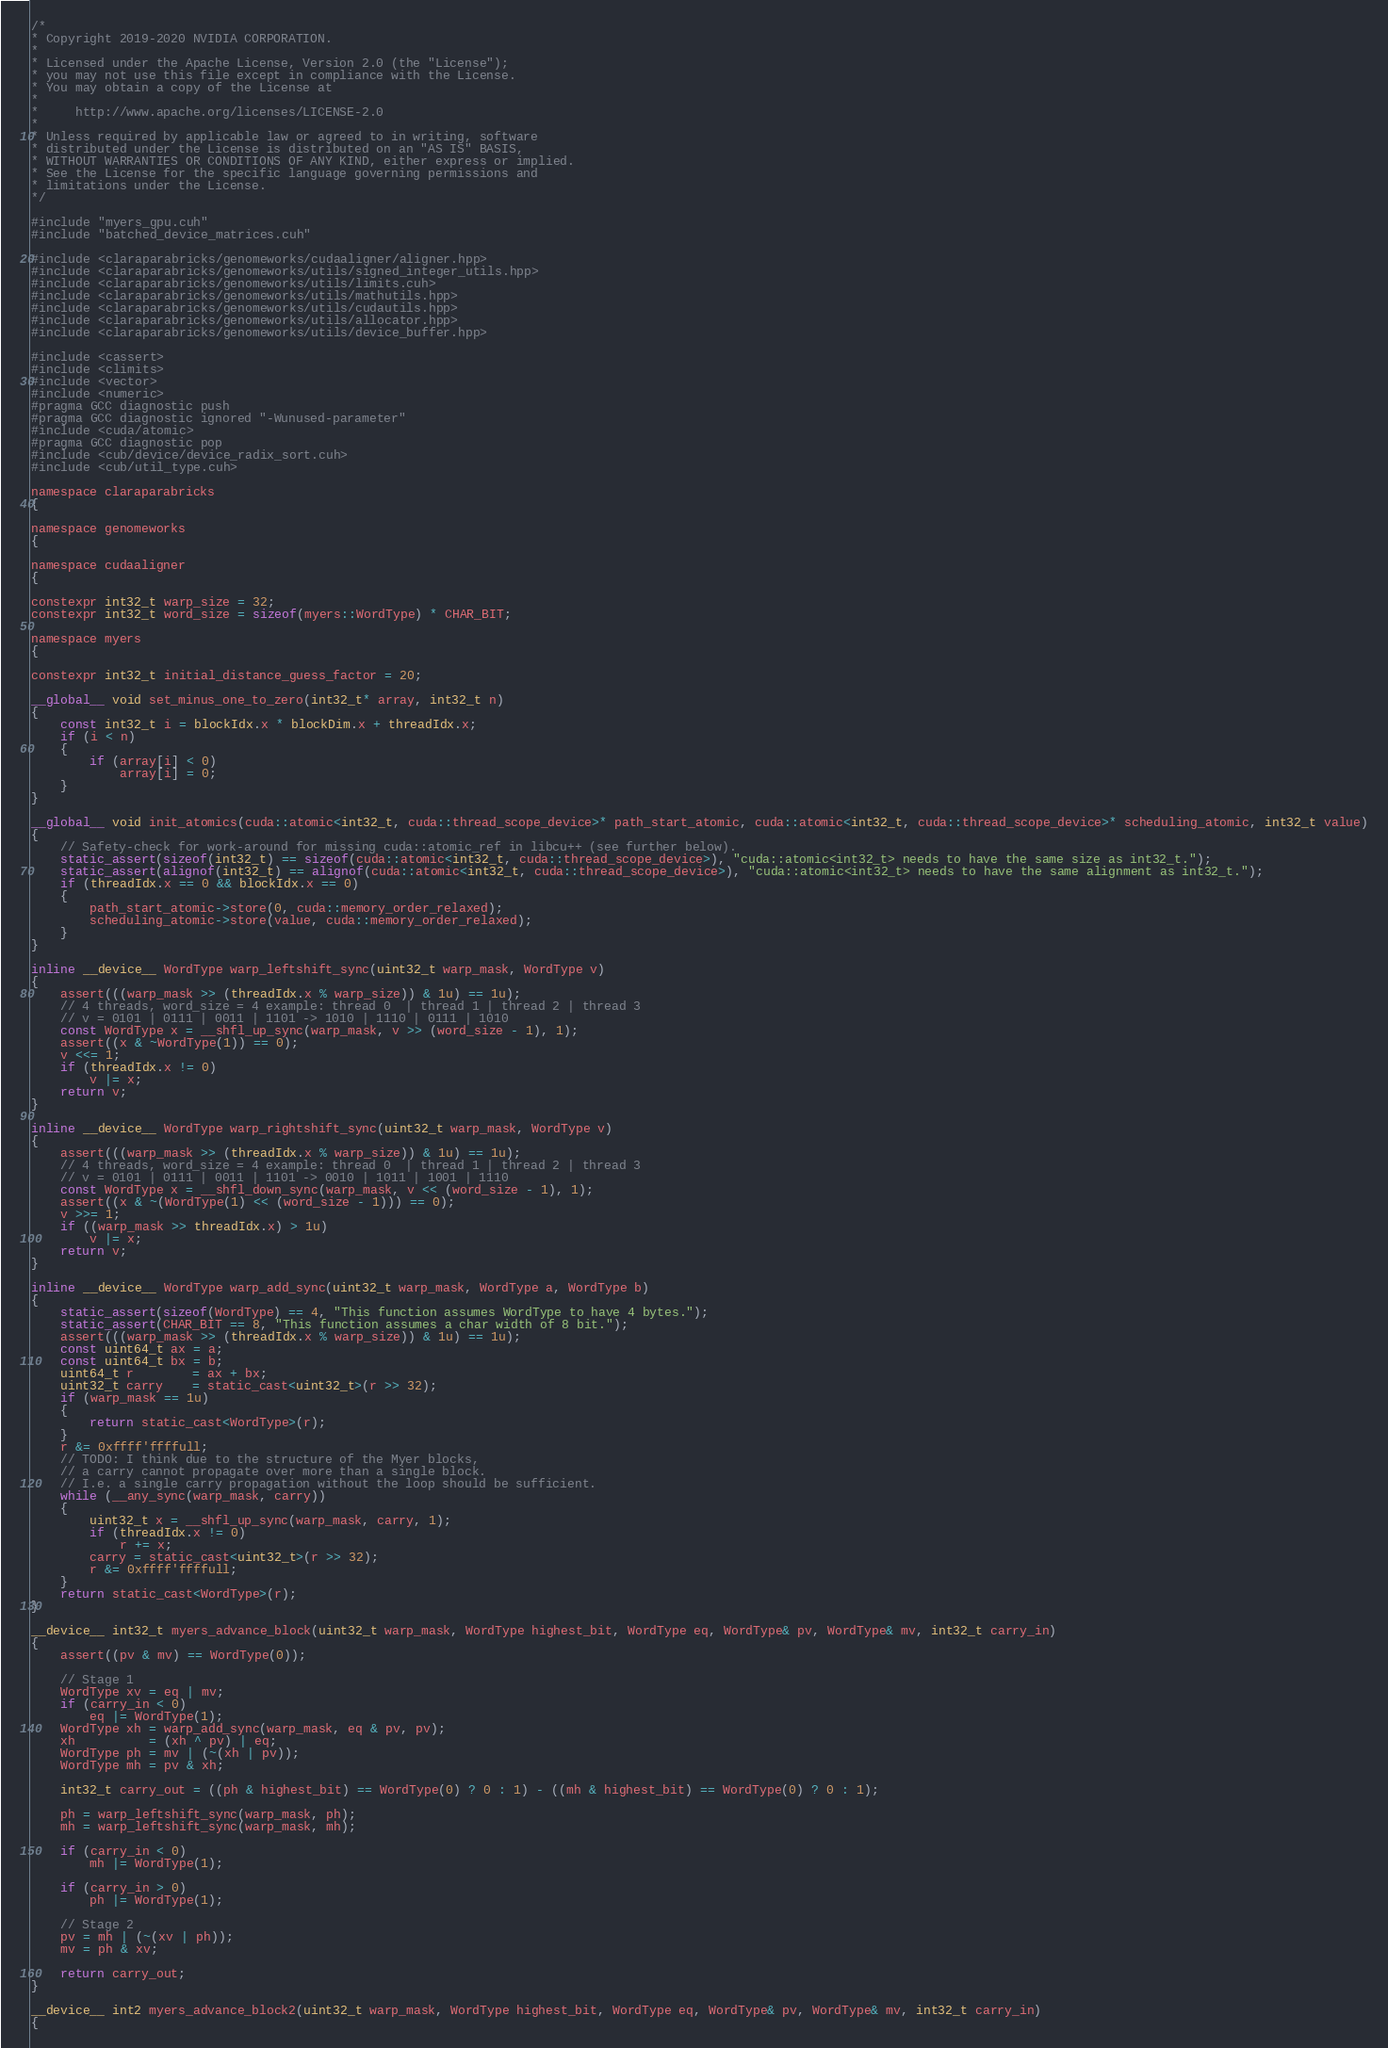<code> <loc_0><loc_0><loc_500><loc_500><_Cuda_>/*
* Copyright 2019-2020 NVIDIA CORPORATION.
*
* Licensed under the Apache License, Version 2.0 (the "License");
* you may not use this file except in compliance with the License.
* You may obtain a copy of the License at
*
*     http://www.apache.org/licenses/LICENSE-2.0
*
* Unless required by applicable law or agreed to in writing, software
* distributed under the License is distributed on an "AS IS" BASIS,
* WITHOUT WARRANTIES OR CONDITIONS OF ANY KIND, either express or implied.
* See the License for the specific language governing permissions and
* limitations under the License.
*/

#include "myers_gpu.cuh"
#include "batched_device_matrices.cuh"

#include <claraparabricks/genomeworks/cudaaligner/aligner.hpp>
#include <claraparabricks/genomeworks/utils/signed_integer_utils.hpp>
#include <claraparabricks/genomeworks/utils/limits.cuh>
#include <claraparabricks/genomeworks/utils/mathutils.hpp>
#include <claraparabricks/genomeworks/utils/cudautils.hpp>
#include <claraparabricks/genomeworks/utils/allocator.hpp>
#include <claraparabricks/genomeworks/utils/device_buffer.hpp>

#include <cassert>
#include <climits>
#include <vector>
#include <numeric>
#pragma GCC diagnostic push
#pragma GCC diagnostic ignored "-Wunused-parameter"
#include <cuda/atomic>
#pragma GCC diagnostic pop
#include <cub/device/device_radix_sort.cuh>
#include <cub/util_type.cuh>

namespace claraparabricks
{

namespace genomeworks
{

namespace cudaaligner
{

constexpr int32_t warp_size = 32;
constexpr int32_t word_size = sizeof(myers::WordType) * CHAR_BIT;

namespace myers
{

constexpr int32_t initial_distance_guess_factor = 20;

__global__ void set_minus_one_to_zero(int32_t* array, int32_t n)
{
    const int32_t i = blockIdx.x * blockDim.x + threadIdx.x;
    if (i < n)
    {
        if (array[i] < 0)
            array[i] = 0;
    }
}

__global__ void init_atomics(cuda::atomic<int32_t, cuda::thread_scope_device>* path_start_atomic, cuda::atomic<int32_t, cuda::thread_scope_device>* scheduling_atomic, int32_t value)
{
    // Safety-check for work-around for missing cuda::atomic_ref in libcu++ (see further below).
    static_assert(sizeof(int32_t) == sizeof(cuda::atomic<int32_t, cuda::thread_scope_device>), "cuda::atomic<int32_t> needs to have the same size as int32_t.");
    static_assert(alignof(int32_t) == alignof(cuda::atomic<int32_t, cuda::thread_scope_device>), "cuda::atomic<int32_t> needs to have the same alignment as int32_t.");
    if (threadIdx.x == 0 && blockIdx.x == 0)
    {
        path_start_atomic->store(0, cuda::memory_order_relaxed);
        scheduling_atomic->store(value, cuda::memory_order_relaxed);
    }
}

inline __device__ WordType warp_leftshift_sync(uint32_t warp_mask, WordType v)
{
    assert(((warp_mask >> (threadIdx.x % warp_size)) & 1u) == 1u);
    // 4 threads, word_size = 4 example: thread 0  | thread 1 | thread 2 | thread 3
    // v = 0101 | 0111 | 0011 | 1101 -> 1010 | 1110 | 0111 | 1010
    const WordType x = __shfl_up_sync(warp_mask, v >> (word_size - 1), 1);
    assert((x & ~WordType(1)) == 0);
    v <<= 1;
    if (threadIdx.x != 0)
        v |= x;
    return v;
}

inline __device__ WordType warp_rightshift_sync(uint32_t warp_mask, WordType v)
{
    assert(((warp_mask >> (threadIdx.x % warp_size)) & 1u) == 1u);
    // 4 threads, word_size = 4 example: thread 0  | thread 1 | thread 2 | thread 3
    // v = 0101 | 0111 | 0011 | 1101 -> 0010 | 1011 | 1001 | 1110
    const WordType x = __shfl_down_sync(warp_mask, v << (word_size - 1), 1);
    assert((x & ~(WordType(1) << (word_size - 1))) == 0);
    v >>= 1;
    if ((warp_mask >> threadIdx.x) > 1u)
        v |= x;
    return v;
}

inline __device__ WordType warp_add_sync(uint32_t warp_mask, WordType a, WordType b)
{
    static_assert(sizeof(WordType) == 4, "This function assumes WordType to have 4 bytes.");
    static_assert(CHAR_BIT == 8, "This function assumes a char width of 8 bit.");
    assert(((warp_mask >> (threadIdx.x % warp_size)) & 1u) == 1u);
    const uint64_t ax = a;
    const uint64_t bx = b;
    uint64_t r        = ax + bx;
    uint32_t carry    = static_cast<uint32_t>(r >> 32);
    if (warp_mask == 1u)
    {
        return static_cast<WordType>(r);
    }
    r &= 0xffff'ffffull;
    // TODO: I think due to the structure of the Myer blocks,
    // a carry cannot propagate over more than a single block.
    // I.e. a single carry propagation without the loop should be sufficient.
    while (__any_sync(warp_mask, carry))
    {
        uint32_t x = __shfl_up_sync(warp_mask, carry, 1);
        if (threadIdx.x != 0)
            r += x;
        carry = static_cast<uint32_t>(r >> 32);
        r &= 0xffff'ffffull;
    }
    return static_cast<WordType>(r);
}

__device__ int32_t myers_advance_block(uint32_t warp_mask, WordType highest_bit, WordType eq, WordType& pv, WordType& mv, int32_t carry_in)
{
    assert((pv & mv) == WordType(0));

    // Stage 1
    WordType xv = eq | mv;
    if (carry_in < 0)
        eq |= WordType(1);
    WordType xh = warp_add_sync(warp_mask, eq & pv, pv);
    xh          = (xh ^ pv) | eq;
    WordType ph = mv | (~(xh | pv));
    WordType mh = pv & xh;

    int32_t carry_out = ((ph & highest_bit) == WordType(0) ? 0 : 1) - ((mh & highest_bit) == WordType(0) ? 0 : 1);

    ph = warp_leftshift_sync(warp_mask, ph);
    mh = warp_leftshift_sync(warp_mask, mh);

    if (carry_in < 0)
        mh |= WordType(1);

    if (carry_in > 0)
        ph |= WordType(1);

    // Stage 2
    pv = mh | (~(xv | ph));
    mv = ph & xv;

    return carry_out;
}

__device__ int2 myers_advance_block2(uint32_t warp_mask, WordType highest_bit, WordType eq, WordType& pv, WordType& mv, int32_t carry_in)
{</code> 